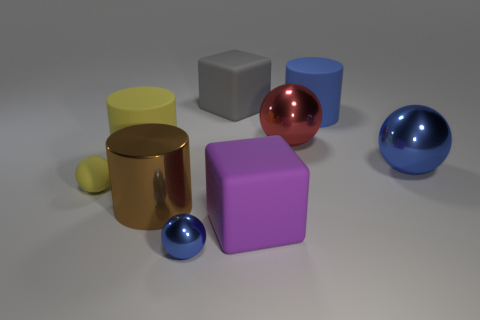Which object stands out most to you, and why? The red sphere catches the eye due to its vibrant color and the way it reflects light. Its position and pronounced color contrast set it apart from the other objects in the image. 